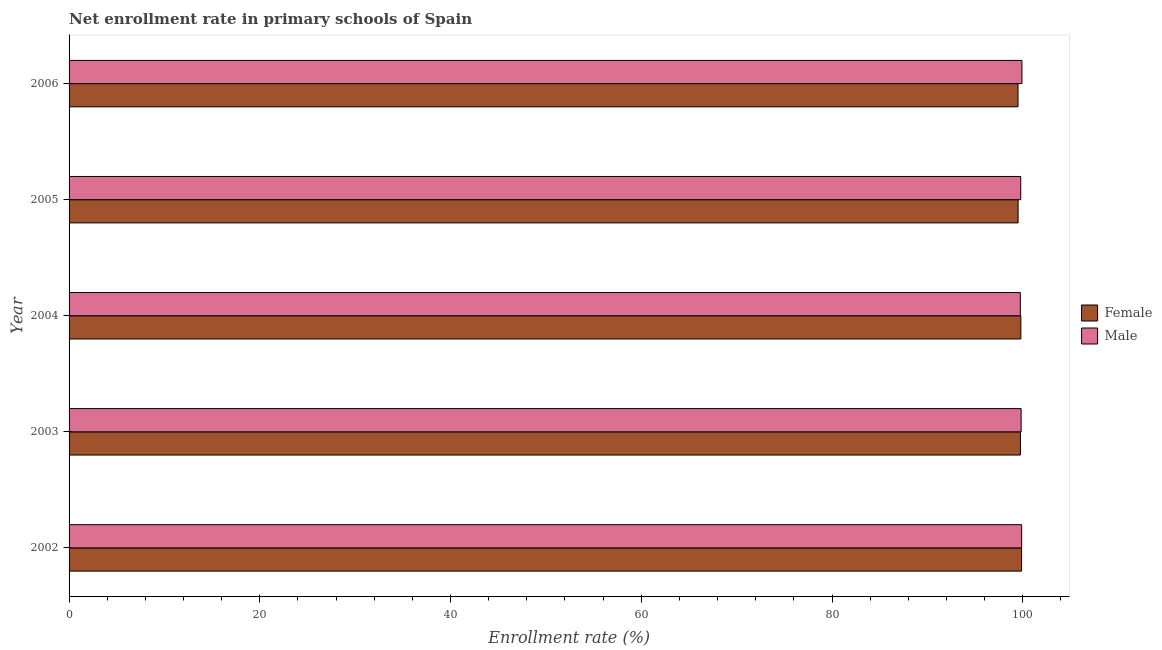How many different coloured bars are there?
Your answer should be compact. 2. How many groups of bars are there?
Provide a short and direct response. 5. How many bars are there on the 4th tick from the top?
Keep it short and to the point. 2. What is the label of the 3rd group of bars from the top?
Offer a terse response. 2004. What is the enrollment rate of male students in 2005?
Provide a succinct answer. 99.79. Across all years, what is the maximum enrollment rate of male students?
Provide a short and direct response. 99.92. Across all years, what is the minimum enrollment rate of male students?
Your answer should be very brief. 99.75. In which year was the enrollment rate of female students maximum?
Provide a succinct answer. 2002. What is the total enrollment rate of male students in the graph?
Ensure brevity in your answer.  499.18. What is the difference between the enrollment rate of female students in 2002 and that in 2006?
Make the answer very short. 0.37. What is the difference between the enrollment rate of male students in 2005 and the enrollment rate of female students in 2004?
Offer a terse response. -0.01. What is the average enrollment rate of female students per year?
Provide a short and direct response. 99.69. In the year 2006, what is the difference between the enrollment rate of male students and enrollment rate of female students?
Give a very brief answer. 0.41. In how many years, is the enrollment rate of female students greater than 76 %?
Offer a terse response. 5. Is the difference between the enrollment rate of female students in 2004 and 2005 greater than the difference between the enrollment rate of male students in 2004 and 2005?
Provide a succinct answer. Yes. What is the difference between the highest and the second highest enrollment rate of female students?
Your answer should be very brief. 0.07. What is the difference between the highest and the lowest enrollment rate of female students?
Keep it short and to the point. 0.37. Is the sum of the enrollment rate of male students in 2003 and 2004 greater than the maximum enrollment rate of female students across all years?
Keep it short and to the point. Yes. What does the 1st bar from the top in 2002 represents?
Offer a terse response. Male. What does the 2nd bar from the bottom in 2003 represents?
Provide a short and direct response. Male. How many bars are there?
Your answer should be very brief. 10. What is the difference between two consecutive major ticks on the X-axis?
Provide a succinct answer. 20. Are the values on the major ticks of X-axis written in scientific E-notation?
Your answer should be compact. No. Where does the legend appear in the graph?
Offer a very short reply. Center right. How are the legend labels stacked?
Keep it short and to the point. Vertical. What is the title of the graph?
Offer a terse response. Net enrollment rate in primary schools of Spain. Does "Merchandise exports" appear as one of the legend labels in the graph?
Give a very brief answer. No. What is the label or title of the X-axis?
Give a very brief answer. Enrollment rate (%). What is the Enrollment rate (%) of Female in 2002?
Ensure brevity in your answer.  99.88. What is the Enrollment rate (%) in Male in 2002?
Make the answer very short. 99.89. What is the Enrollment rate (%) of Female in 2003?
Keep it short and to the point. 99.76. What is the Enrollment rate (%) in Male in 2003?
Your response must be concise. 99.83. What is the Enrollment rate (%) in Female in 2004?
Your answer should be compact. 99.81. What is the Enrollment rate (%) of Male in 2004?
Ensure brevity in your answer.  99.75. What is the Enrollment rate (%) of Female in 2005?
Keep it short and to the point. 99.52. What is the Enrollment rate (%) of Male in 2005?
Provide a short and direct response. 99.79. What is the Enrollment rate (%) of Female in 2006?
Ensure brevity in your answer.  99.51. What is the Enrollment rate (%) in Male in 2006?
Offer a terse response. 99.92. Across all years, what is the maximum Enrollment rate (%) of Female?
Your response must be concise. 99.88. Across all years, what is the maximum Enrollment rate (%) in Male?
Your answer should be compact. 99.92. Across all years, what is the minimum Enrollment rate (%) of Female?
Offer a terse response. 99.51. Across all years, what is the minimum Enrollment rate (%) in Male?
Offer a very short reply. 99.75. What is the total Enrollment rate (%) in Female in the graph?
Your answer should be very brief. 498.47. What is the total Enrollment rate (%) of Male in the graph?
Your answer should be very brief. 499.18. What is the difference between the Enrollment rate (%) of Female in 2002 and that in 2003?
Your answer should be very brief. 0.12. What is the difference between the Enrollment rate (%) of Male in 2002 and that in 2003?
Provide a short and direct response. 0.06. What is the difference between the Enrollment rate (%) of Female in 2002 and that in 2004?
Give a very brief answer. 0.07. What is the difference between the Enrollment rate (%) of Male in 2002 and that in 2004?
Offer a terse response. 0.14. What is the difference between the Enrollment rate (%) in Female in 2002 and that in 2005?
Give a very brief answer. 0.36. What is the difference between the Enrollment rate (%) of Male in 2002 and that in 2005?
Make the answer very short. 0.09. What is the difference between the Enrollment rate (%) in Female in 2002 and that in 2006?
Offer a terse response. 0.37. What is the difference between the Enrollment rate (%) of Male in 2002 and that in 2006?
Give a very brief answer. -0.03. What is the difference between the Enrollment rate (%) in Female in 2003 and that in 2004?
Ensure brevity in your answer.  -0.04. What is the difference between the Enrollment rate (%) in Male in 2003 and that in 2004?
Your response must be concise. 0.08. What is the difference between the Enrollment rate (%) in Female in 2003 and that in 2005?
Your answer should be very brief. 0.24. What is the difference between the Enrollment rate (%) in Male in 2003 and that in 2005?
Ensure brevity in your answer.  0.04. What is the difference between the Enrollment rate (%) of Female in 2003 and that in 2006?
Your answer should be compact. 0.25. What is the difference between the Enrollment rate (%) in Male in 2003 and that in 2006?
Keep it short and to the point. -0.09. What is the difference between the Enrollment rate (%) of Female in 2004 and that in 2005?
Your answer should be compact. 0.29. What is the difference between the Enrollment rate (%) of Male in 2004 and that in 2005?
Offer a very short reply. -0.05. What is the difference between the Enrollment rate (%) in Female in 2004 and that in 2006?
Keep it short and to the point. 0.3. What is the difference between the Enrollment rate (%) in Male in 2004 and that in 2006?
Provide a short and direct response. -0.17. What is the difference between the Enrollment rate (%) in Female in 2005 and that in 2006?
Provide a succinct answer. 0.01. What is the difference between the Enrollment rate (%) of Male in 2005 and that in 2006?
Make the answer very short. -0.12. What is the difference between the Enrollment rate (%) of Female in 2002 and the Enrollment rate (%) of Male in 2003?
Provide a succinct answer. 0.05. What is the difference between the Enrollment rate (%) of Female in 2002 and the Enrollment rate (%) of Male in 2004?
Your response must be concise. 0.13. What is the difference between the Enrollment rate (%) of Female in 2002 and the Enrollment rate (%) of Male in 2005?
Offer a terse response. 0.09. What is the difference between the Enrollment rate (%) in Female in 2002 and the Enrollment rate (%) in Male in 2006?
Offer a terse response. -0.04. What is the difference between the Enrollment rate (%) in Female in 2003 and the Enrollment rate (%) in Male in 2004?
Your response must be concise. 0.01. What is the difference between the Enrollment rate (%) of Female in 2003 and the Enrollment rate (%) of Male in 2005?
Ensure brevity in your answer.  -0.03. What is the difference between the Enrollment rate (%) of Female in 2003 and the Enrollment rate (%) of Male in 2006?
Your answer should be compact. -0.16. What is the difference between the Enrollment rate (%) of Female in 2004 and the Enrollment rate (%) of Male in 2005?
Your answer should be very brief. 0.01. What is the difference between the Enrollment rate (%) of Female in 2004 and the Enrollment rate (%) of Male in 2006?
Your response must be concise. -0.11. What is the difference between the Enrollment rate (%) in Female in 2005 and the Enrollment rate (%) in Male in 2006?
Your response must be concise. -0.4. What is the average Enrollment rate (%) of Female per year?
Make the answer very short. 99.69. What is the average Enrollment rate (%) in Male per year?
Give a very brief answer. 99.84. In the year 2002, what is the difference between the Enrollment rate (%) in Female and Enrollment rate (%) in Male?
Offer a very short reply. -0.01. In the year 2003, what is the difference between the Enrollment rate (%) of Female and Enrollment rate (%) of Male?
Your answer should be very brief. -0.07. In the year 2004, what is the difference between the Enrollment rate (%) in Female and Enrollment rate (%) in Male?
Make the answer very short. 0.06. In the year 2005, what is the difference between the Enrollment rate (%) of Female and Enrollment rate (%) of Male?
Keep it short and to the point. -0.28. In the year 2006, what is the difference between the Enrollment rate (%) of Female and Enrollment rate (%) of Male?
Provide a short and direct response. -0.41. What is the ratio of the Enrollment rate (%) of Female in 2002 to that in 2005?
Your answer should be very brief. 1. What is the ratio of the Enrollment rate (%) of Male in 2002 to that in 2005?
Offer a terse response. 1. What is the ratio of the Enrollment rate (%) in Female in 2003 to that in 2004?
Offer a very short reply. 1. What is the ratio of the Enrollment rate (%) in Male in 2003 to that in 2006?
Provide a short and direct response. 1. What is the ratio of the Enrollment rate (%) of Male in 2004 to that in 2005?
Ensure brevity in your answer.  1. What is the ratio of the Enrollment rate (%) of Female in 2004 to that in 2006?
Give a very brief answer. 1. What is the ratio of the Enrollment rate (%) in Female in 2005 to that in 2006?
Give a very brief answer. 1. What is the difference between the highest and the second highest Enrollment rate (%) of Female?
Give a very brief answer. 0.07. What is the difference between the highest and the second highest Enrollment rate (%) in Male?
Offer a very short reply. 0.03. What is the difference between the highest and the lowest Enrollment rate (%) in Female?
Provide a succinct answer. 0.37. What is the difference between the highest and the lowest Enrollment rate (%) in Male?
Offer a very short reply. 0.17. 